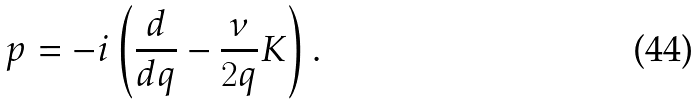<formula> <loc_0><loc_0><loc_500><loc_500>p = - i \left ( \frac { d } { d q } - \frac { \nu } { 2 q } K \right ) .</formula> 